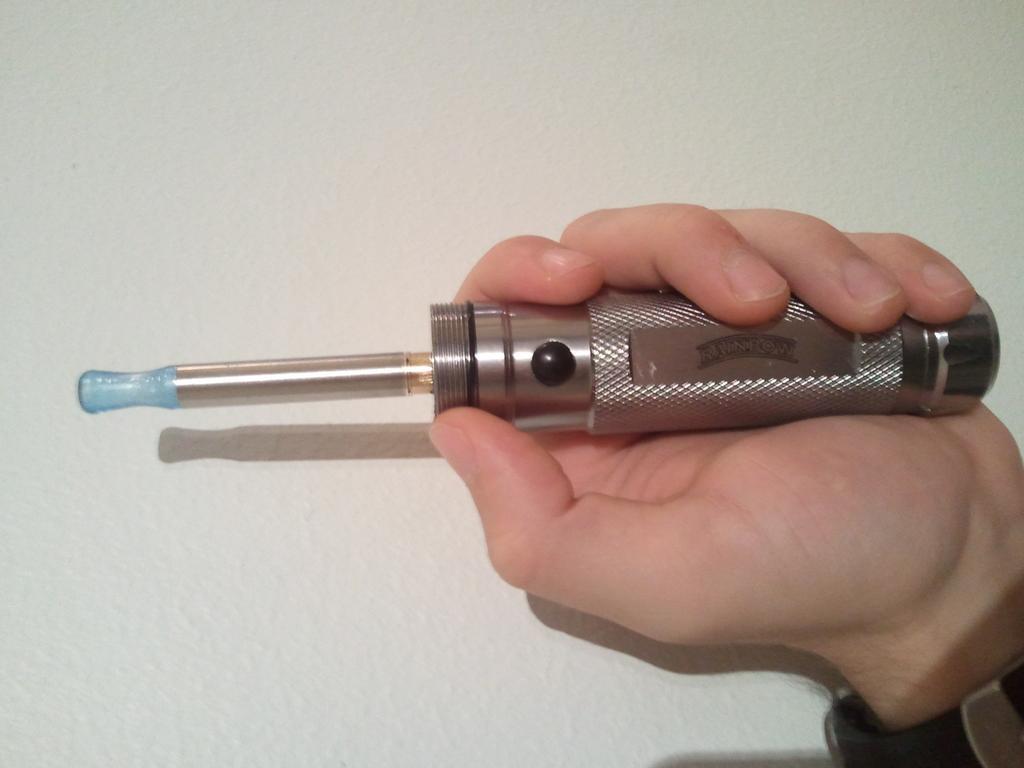Could you give a brief overview of what you see in this image? In this image I can see the person is holding the object. Background is in white color. 